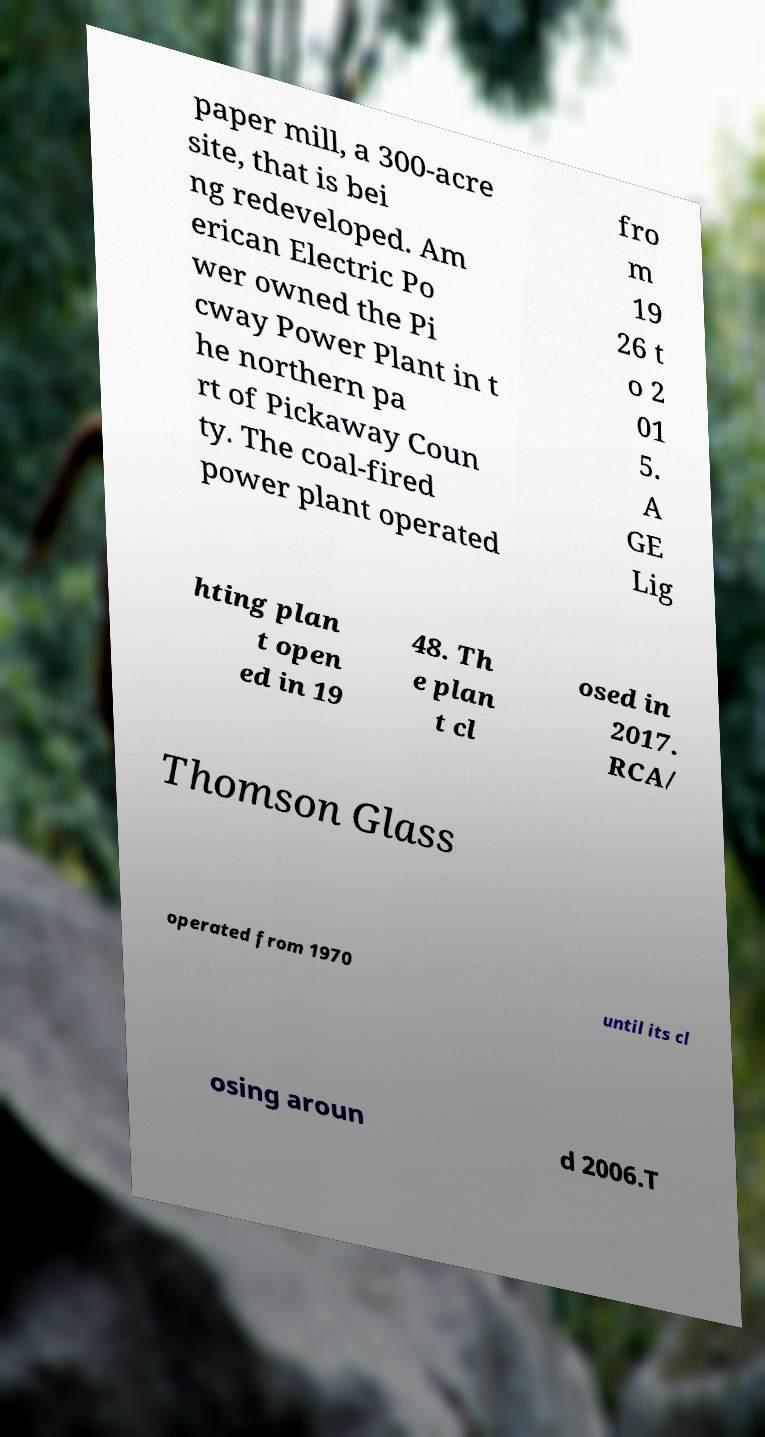I need the written content from this picture converted into text. Can you do that? paper mill, a 300-acre site, that is bei ng redeveloped. Am erican Electric Po wer owned the Pi cway Power Plant in t he northern pa rt of Pickaway Coun ty. The coal-fired power plant operated fro m 19 26 t o 2 01 5. A GE Lig hting plan t open ed in 19 48. Th e plan t cl osed in 2017. RCA/ Thomson Glass operated from 1970 until its cl osing aroun d 2006.T 